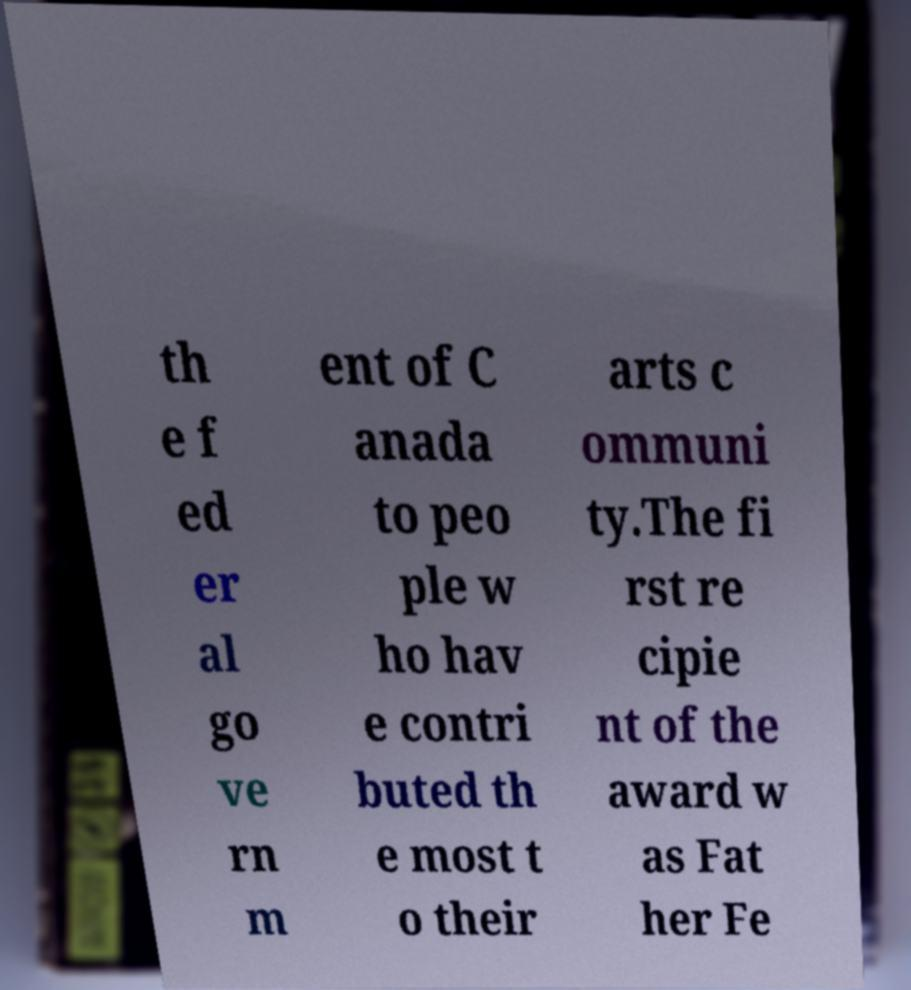There's text embedded in this image that I need extracted. Can you transcribe it verbatim? th e f ed er al go ve rn m ent of C anada to peo ple w ho hav e contri buted th e most t o their arts c ommuni ty.The fi rst re cipie nt of the award w as Fat her Fe 